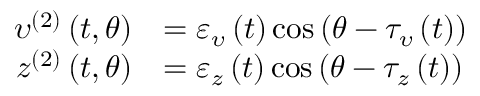Convert formula to latex. <formula><loc_0><loc_0><loc_500><loc_500>\begin{array} { r l } { \upsilon ^ { ( 2 ) } \left ( t , \theta \right ) } & { = \varepsilon _ { \upsilon } \left ( t \right ) \cos \left ( \theta - \tau _ { \upsilon } \left ( t \right ) \right ) } \\ { z ^ { ( 2 ) } \left ( t , \theta \right ) } & { = \varepsilon _ { z } \left ( t \right ) \cos \left ( \theta - \tau _ { z } \left ( t \right ) \right ) } \end{array}</formula> 